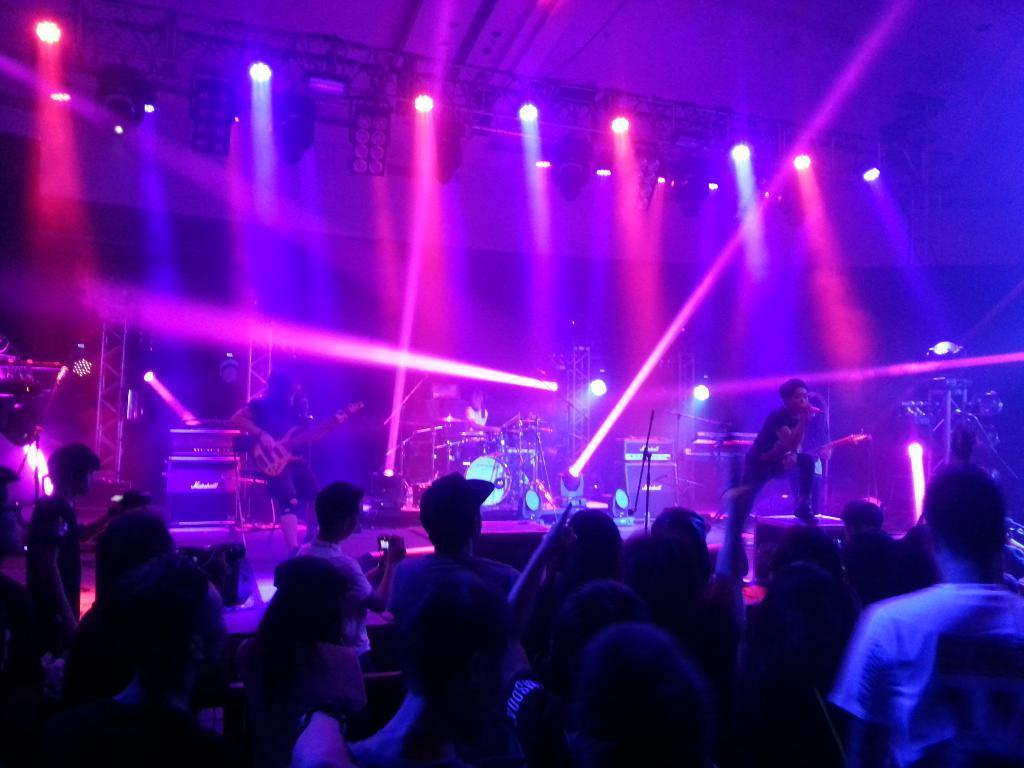Can you describe this image briefly? In this picture there are musicians performing on the stage and in front there are the crowds enjoying the performance of these musicians. In the background there are spotlights. On the stage there are musical instrument. At the left side the person is holding musical instrument in his hand. At the right side the man is standing and is singing. 